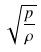Convert formula to latex. <formula><loc_0><loc_0><loc_500><loc_500>\sqrt { \frac { p } { \rho } }</formula> 